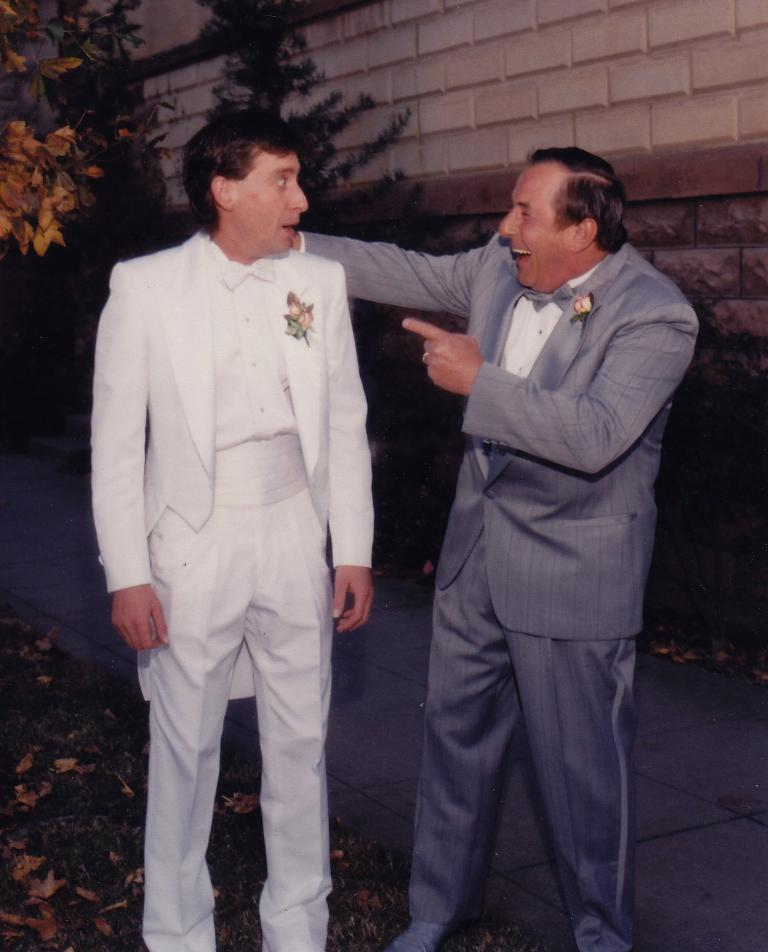How many people are in the image? There are two men standing in the image. What can be seen in the background of the image? There is a brick wall in the background of the image. What type of vegetation is visible in the image? There are branches of trees in the image. What is present on the ground in the image? Dried leaves are present on the ground in the image. Can you see a snail moving across the brick wall in the image? There is no snail present in the image, so it cannot be seen moving across the brick wall. 